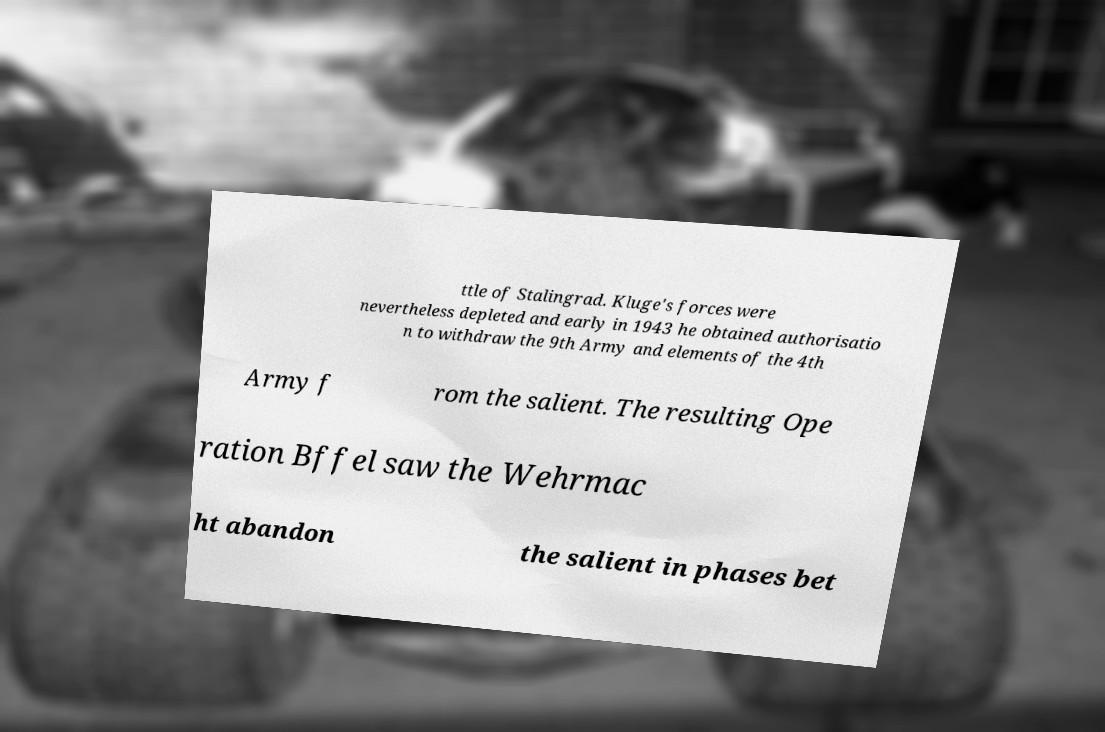I need the written content from this picture converted into text. Can you do that? ttle of Stalingrad. Kluge's forces were nevertheless depleted and early in 1943 he obtained authorisatio n to withdraw the 9th Army and elements of the 4th Army f rom the salient. The resulting Ope ration Bffel saw the Wehrmac ht abandon the salient in phases bet 